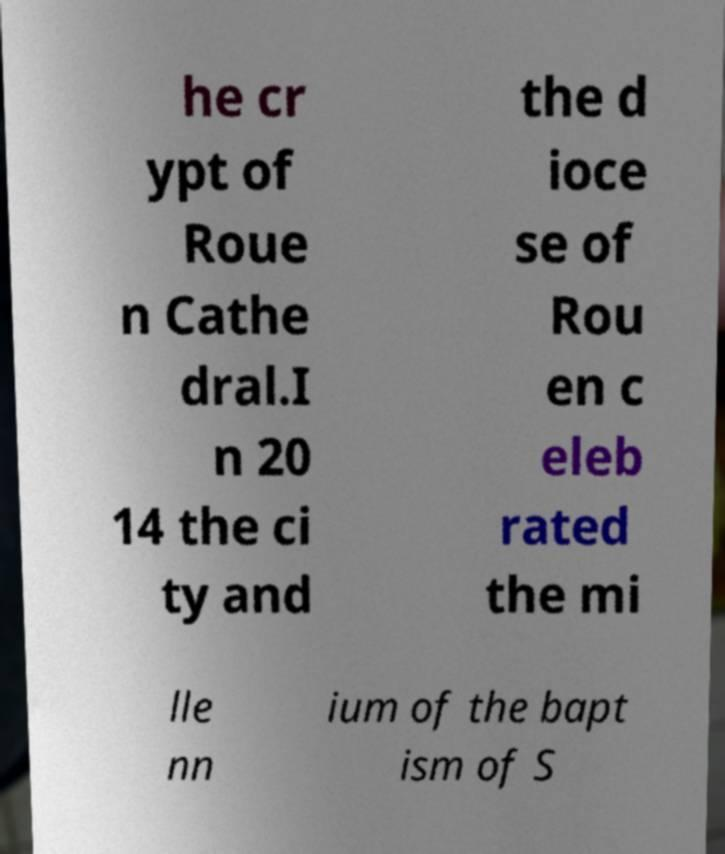Can you accurately transcribe the text from the provided image for me? he cr ypt of Roue n Cathe dral.I n 20 14 the ci ty and the d ioce se of Rou en c eleb rated the mi lle nn ium of the bapt ism of S 